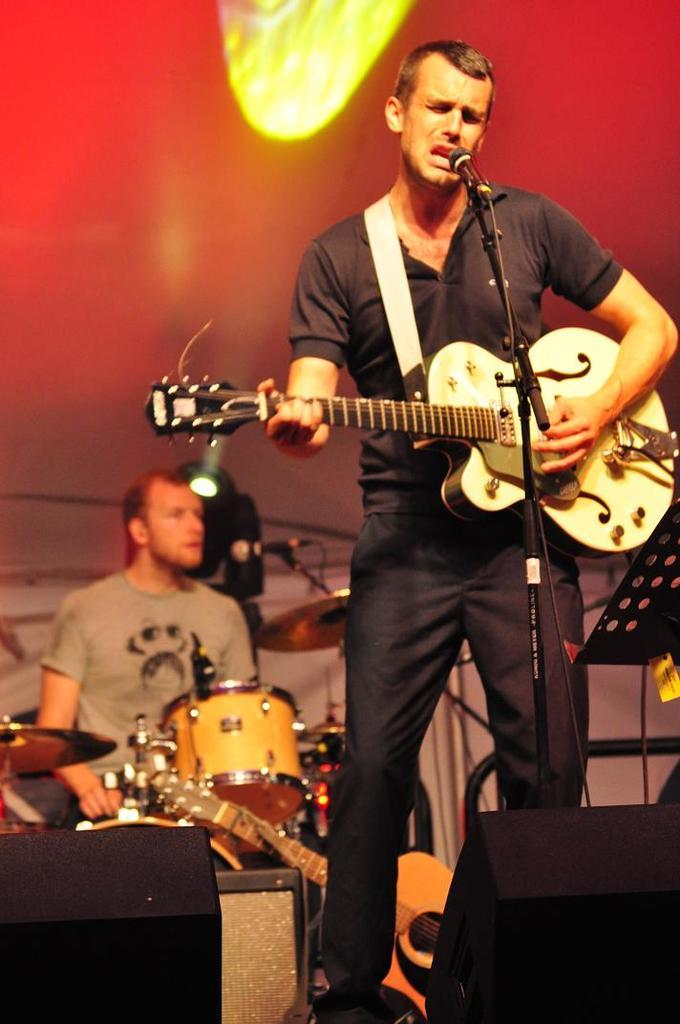What is the man in the image doing? The man is playing a guitar and singing. What is the man's position in relation to the microphone? The man is in front of a microphone. Are there any other musicians in the image? Yes, there is another person playing musical instruments. What can be seen at the top of the image? There are focusing lights visible at the top of the image. What type of trousers is the man wearing while playing the guitar? The provided facts do not mention the type of trousers the man is wearing, so we cannot answer this question. --- Facts: 1. There is a group of people standing in a circle. 2. The people are holding hands. 3. There is a tree in the background of the image. 4. The sky is visible in the background of the image. 5. The people are wearing casual clothing. Absurd Topics: parrot, sandcastle, telescope Conversation: What are the people in the image doing? The people are standing in a circle and holding hands. What can be seen in the background of the image? There is a tree and the sky visible in the background of the image. What type of clothing are the people wearing? The people are wearing casual clothing. Reasoning: Let's think step by step in order to produce the conversation. We start by identifying the main subject in the image, which is the group of people standing in a circle and holding hands. Then, we expand the conversation to include the background of the image, which features a tree and the sky. Finally, we mention the casual clothing worn by the people. Each question is designed to elicit a specific detail about the image that is known from the provided facts. Absurd Question/Answer: Can you see a parrot perched on the tree in the background of the image? There is no mention of a parrot in the provided facts, so we cannot answer this question. 